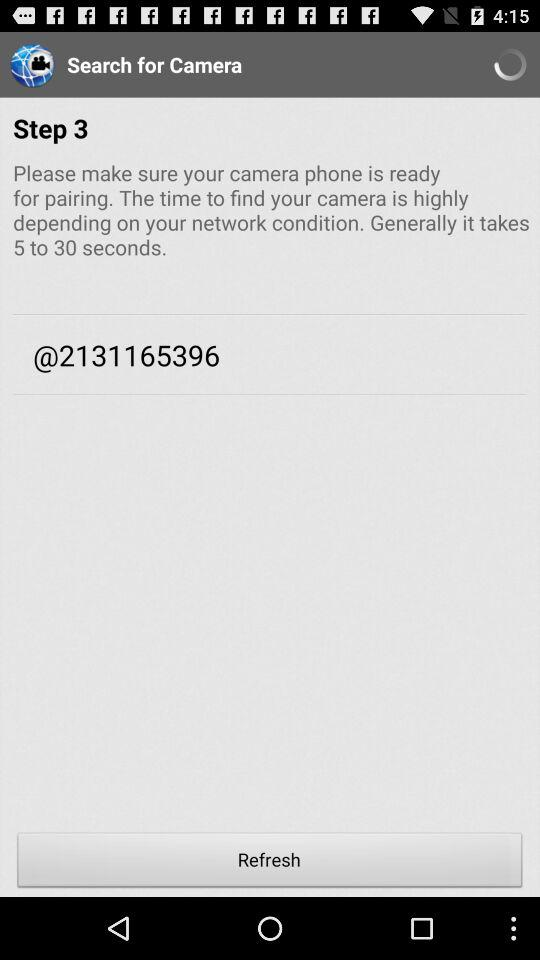What is the step number shown currently? The step number is 3. 